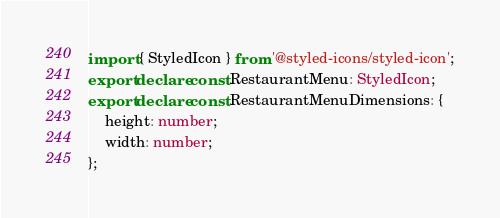Convert code to text. <code><loc_0><loc_0><loc_500><loc_500><_TypeScript_>import { StyledIcon } from '@styled-icons/styled-icon';
export declare const RestaurantMenu: StyledIcon;
export declare const RestaurantMenuDimensions: {
    height: number;
    width: number;
};
</code> 